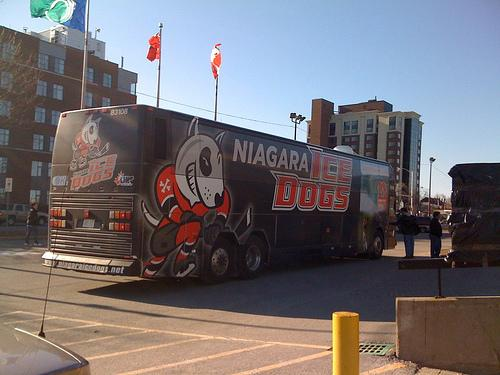What sport is the cartoon dog playing? hockey 